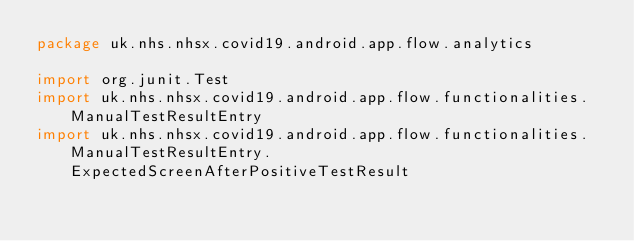Convert code to text. <code><loc_0><loc_0><loc_500><loc_500><_Kotlin_>package uk.nhs.nhsx.covid19.android.app.flow.analytics

import org.junit.Test
import uk.nhs.nhsx.covid19.android.app.flow.functionalities.ManualTestResultEntry
import uk.nhs.nhsx.covid19.android.app.flow.functionalities.ManualTestResultEntry.ExpectedScreenAfterPositiveTestResult</code> 